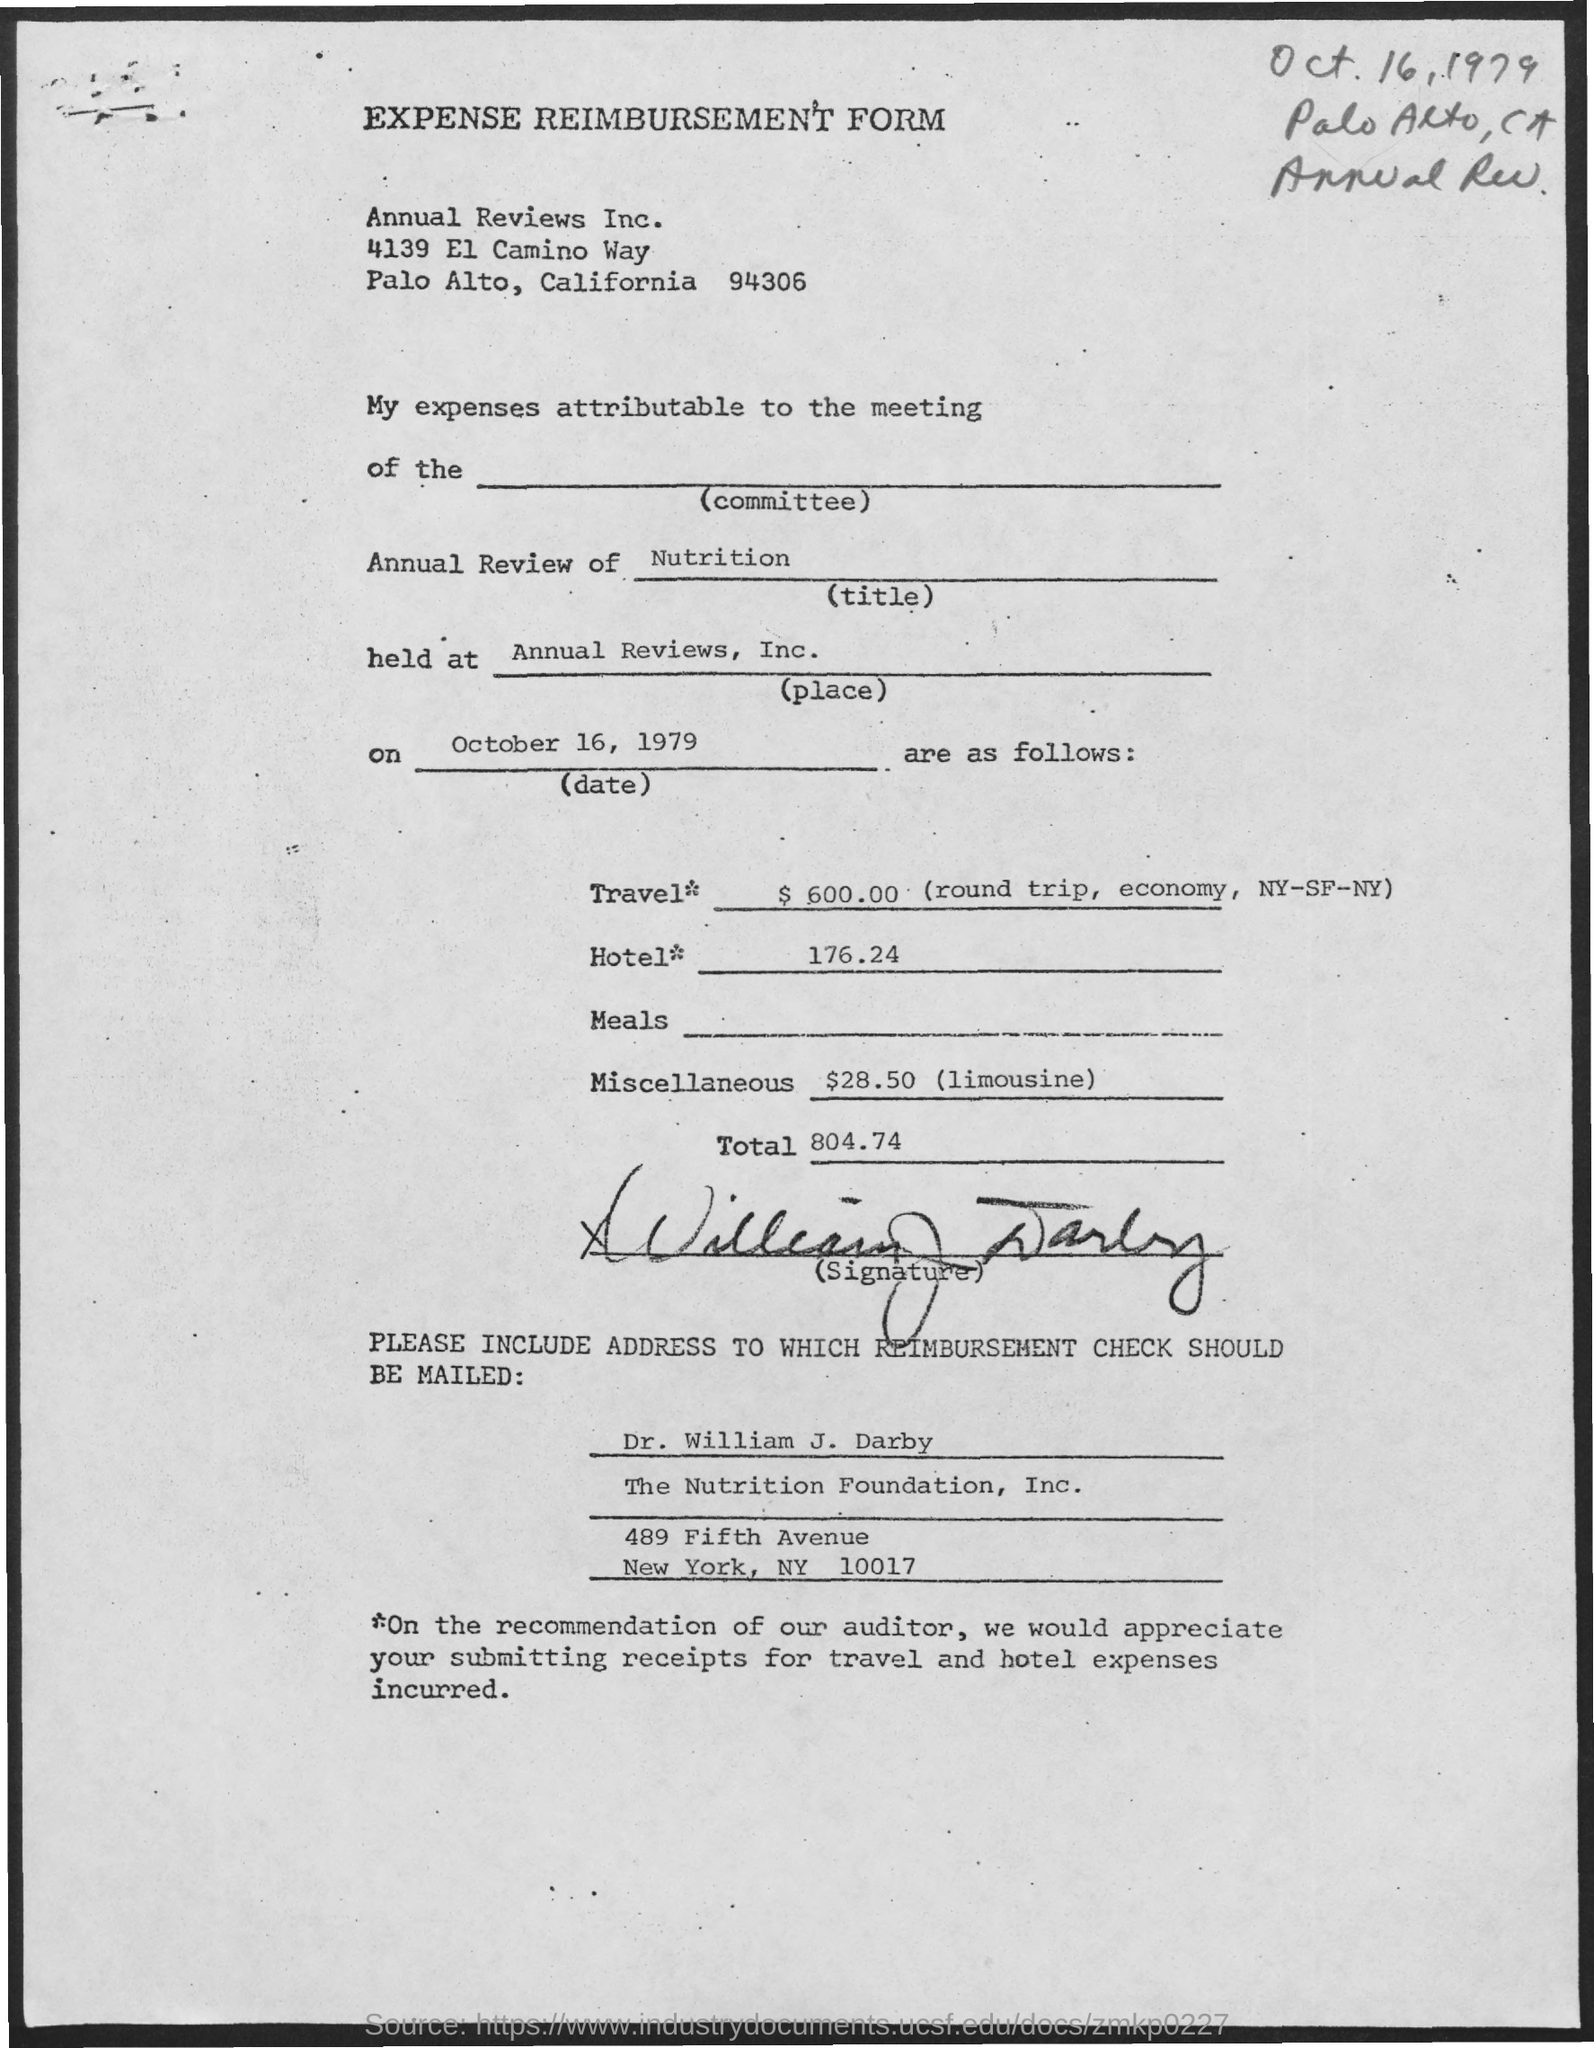Highlight a few significant elements in this photo. The total amount for the hotel is 176.24. The Annual Review Field contains the written information 'Nutrition'. The expenses for travel are expected to be $600.00. 